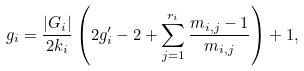<formula> <loc_0><loc_0><loc_500><loc_500>g _ { i } = \frac { | G _ { i } | } { 2 k _ { i } } \left ( 2 g _ { i } ^ { \prime } - 2 + \sum _ { j = 1 } ^ { r _ { i } } \frac { m _ { i , j } - 1 } { m _ { i , j } } \right ) + 1 ,</formula> 